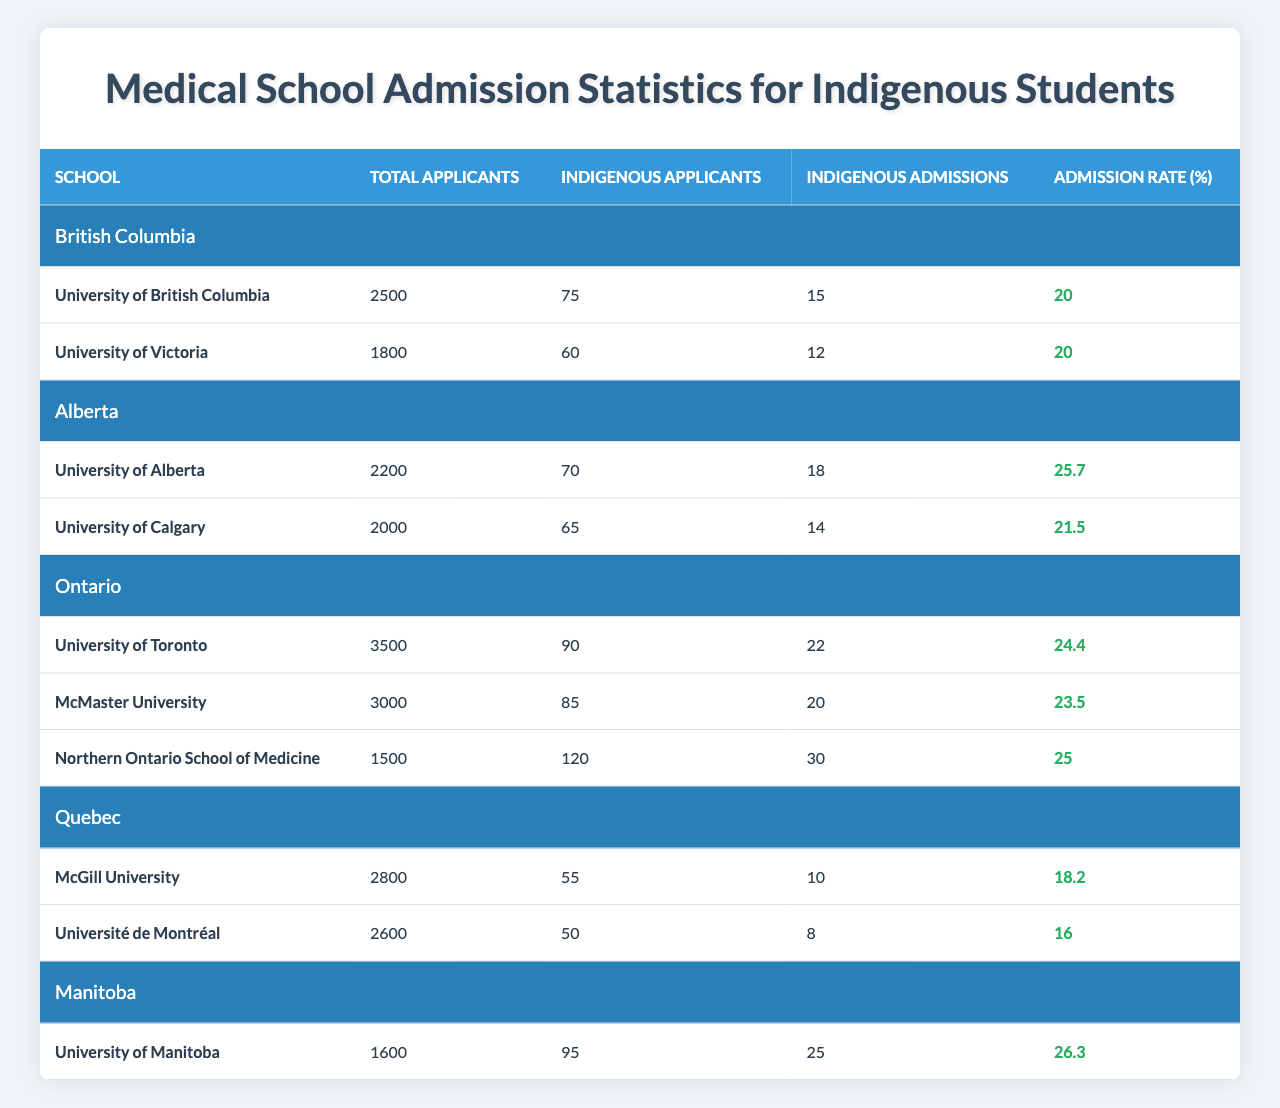What is the highest admission rate for Indigenous students among the schools listed? By examining the "Admission Rate (%)" column in the table, we see that the University of Alberta has the highest admission rate at 25.7%.
Answer: 25.7% Which province has the most medical schools listed? The data shows that Ontario has three schools listed: University of Toronto, McMaster University, and Northern Ontario School of Medicine, while other provinces have fewer than that.
Answer: Ontario How many Indigenous applicants were there at McGill University? The table specifically states that McGill University had 55 Indigenous applicants.
Answer: 55 What is the average Indigenous admission rate for the schools in British Columbia? The admission rates for the two schools are both 20%. We add these rates together: 20 + 20 = 40, and then divide by 2 to get the average: 40/2 = 20%.
Answer: 20% Was the total number of Indigenous admissions at the University of Toronto more than the total number of Indigenous admissions at McMaster University? The table shows that the University of Toronto had 22 admissions, while McMaster University had 20 admissions, indicating that Toronto had more.
Answer: Yes What is the total number of Indigenous applicants across all provinces listed? We sum the Indigenous applicants for all the schools: 75 + 60 (BC) + 70 + 65 (AB) + 90 + 85 + 120 (ON) + 55 + 50 (QC) + 95 (MB) =  585.
Answer: 585 Which school had the smallest number of Indigenous admissions? The data indicates that Université de Montréal had the smallest number with 8 Indigenous admissions.
Answer: Université de Montréal If we compare the admission rate of the University of Calgary and the University of Victoria, which one has a higher admission rate? The University of Calgary has an admission rate of 21.5%, while the University of Victoria has 20%. Comparing these, Calgary has the higher rate at 21.5%.
Answer: University of Calgary What percentage of Indigenous applicants were admitted at the University of Manitoba? The Indigenous admissions at the University of Manitoba were 25 out of 95 applicants, leading to a calculation of (25/95) * 100 ≈ 26.3%.
Answer: 26.3% Are there more Indigenous admissions in total in Alberta compared to Manitoba? In Alberta, the total Indigenous admissions are 18 (University of Alberta) + 14 (University of Calgary) = 32, while in Manitoba it’s 25, thus Alberta has more.
Answer: Yes What is the total number of applicants for all schools in Quebec? We add the total number of applicants for McGill University (2800) and Université de Montréal (2600) which equals 2800 + 2600 = 5400.
Answer: 5400 